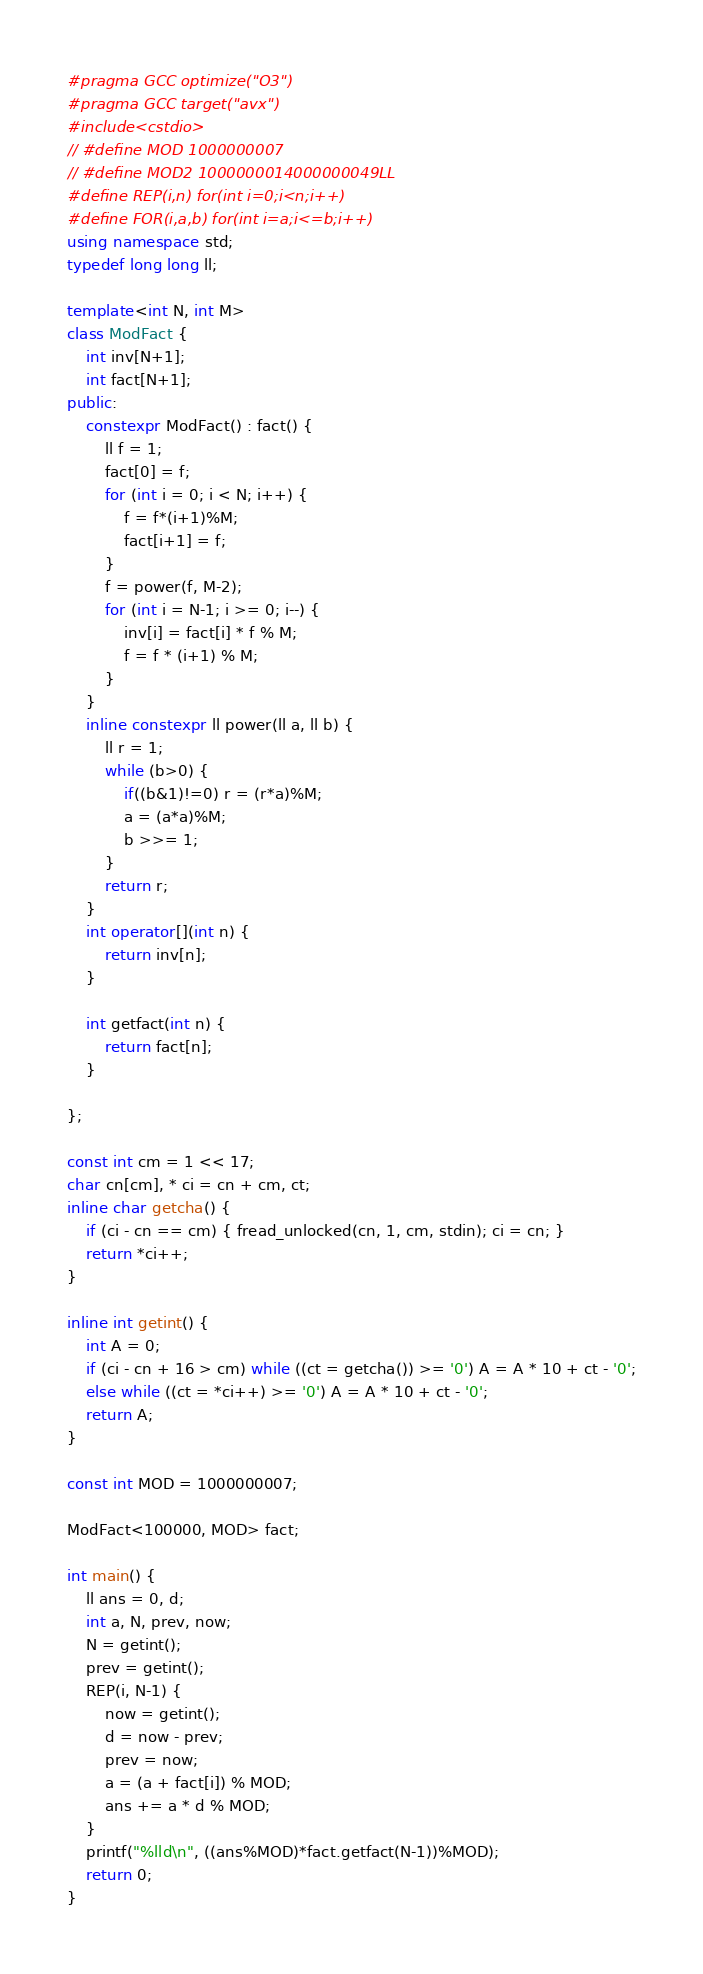Convert code to text. <code><loc_0><loc_0><loc_500><loc_500><_C++_>#pragma GCC optimize("O3")
#pragma GCC target("avx")
#include<cstdio>
// #define MOD 1000000007
// #define MOD2 1000000014000000049LL
#define REP(i,n) for(int i=0;i<n;i++)
#define FOR(i,a,b) for(int i=a;i<=b;i++)
using namespace std;
typedef long long ll;

template<int N, int M>
class ModFact {
    int inv[N+1];
    int fact[N+1];
public:
    constexpr ModFact() : fact() {
        ll f = 1;
        fact[0] = f;
        for (int i = 0; i < N; i++) {
            f = f*(i+1)%M;
            fact[i+1] = f;
        }
        f = power(f, M-2);
        for (int i = N-1; i >= 0; i--) {
            inv[i] = fact[i] * f % M;
            f = f * (i+1) % M;
        }
    }
    inline constexpr ll power(ll a, ll b) {
        ll r = 1;
        while (b>0) {
            if((b&1)!=0) r = (r*a)%M;
            a = (a*a)%M;
            b >>= 1;
        }
        return r;
    }
	int operator[](int n) {
		return inv[n];
	}

	int getfact(int n) {
		return fact[n];
	}
    
};

const int cm = 1 << 17;
char cn[cm], * ci = cn + cm, ct;
inline char getcha() {
	if (ci - cn == cm) { fread_unlocked(cn, 1, cm, stdin); ci = cn; }
	return *ci++;
}

inline int getint() {
	int A = 0;
	if (ci - cn + 16 > cm) while ((ct = getcha()) >= '0') A = A * 10 + ct - '0';
	else while ((ct = *ci++) >= '0') A = A * 10 + ct - '0';
	return A;
}

const int MOD = 1000000007;

ModFact<100000, MOD> fact;

int main() {
    ll ans = 0, d;
    int a, N, prev, now;
    N = getint();
    prev = getint();
    REP(i, N-1) {
        now = getint();
        d = now - prev;
        prev = now;
        a = (a + fact[i]) % MOD;
        ans += a * d % MOD;
    }
    printf("%lld\n", ((ans%MOD)*fact.getfact(N-1))%MOD);
	return 0;
}
</code> 